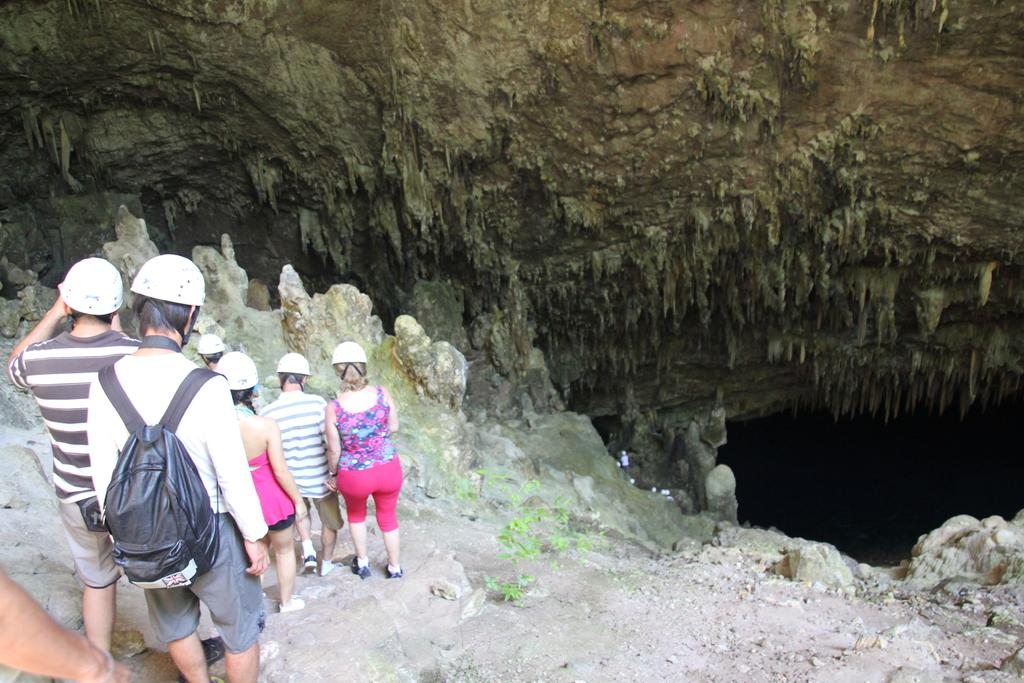What are the persons in the image wearing on their heads? The persons in the image are wearing helmets. Can you describe any additional accessories worn by one of the persons? One of the persons is wearing a black colored bag. What can be seen in the distance in the image? There is a mountain and a cave in the background of the image. What type of pail can be seen being used by the persons in the image? There is no pail visible in the image. Is there a railway present in the image? No, there is no railway present in the image. 